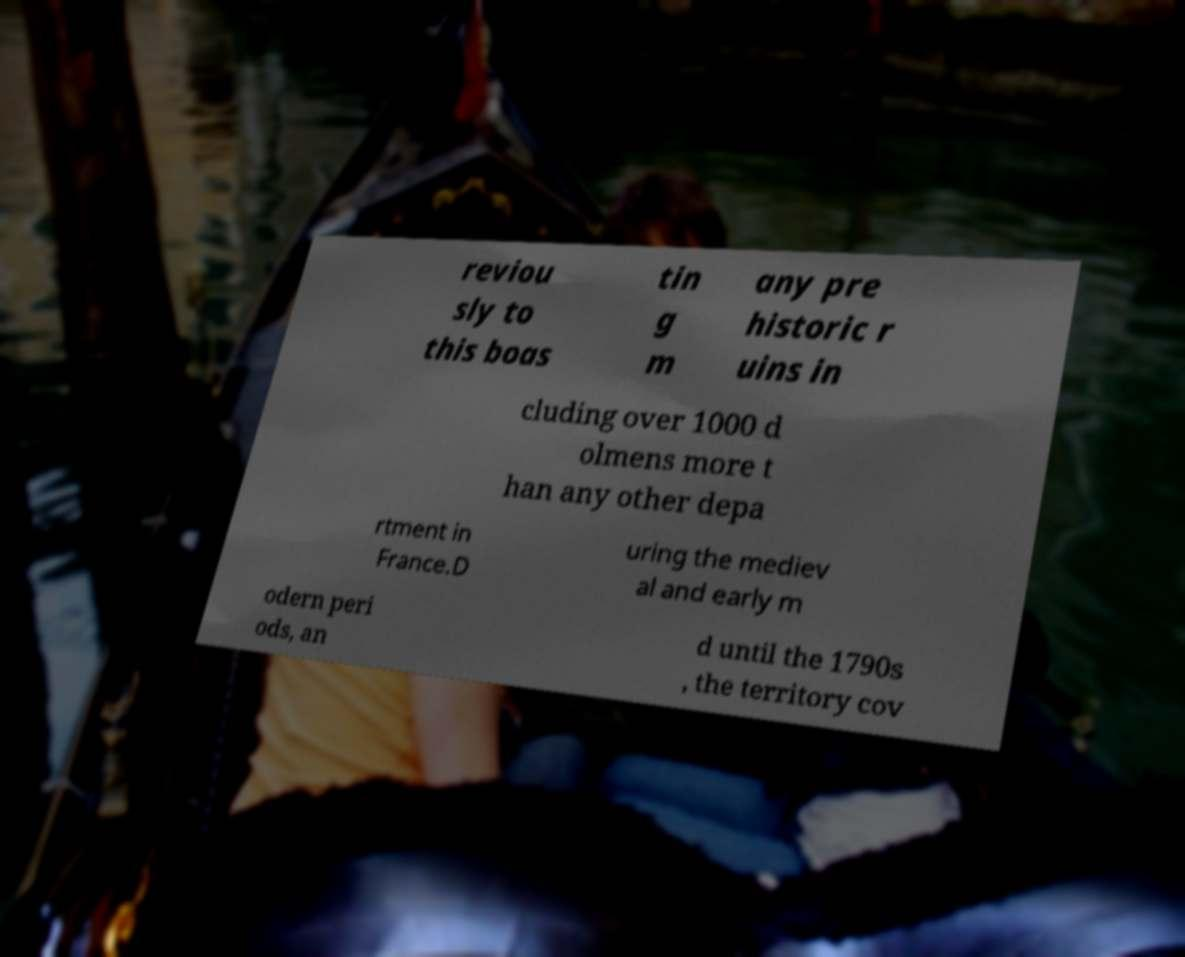There's text embedded in this image that I need extracted. Can you transcribe it verbatim? reviou sly to this boas tin g m any pre historic r uins in cluding over 1000 d olmens more t han any other depa rtment in France.D uring the mediev al and early m odern peri ods, an d until the 1790s , the territory cov 